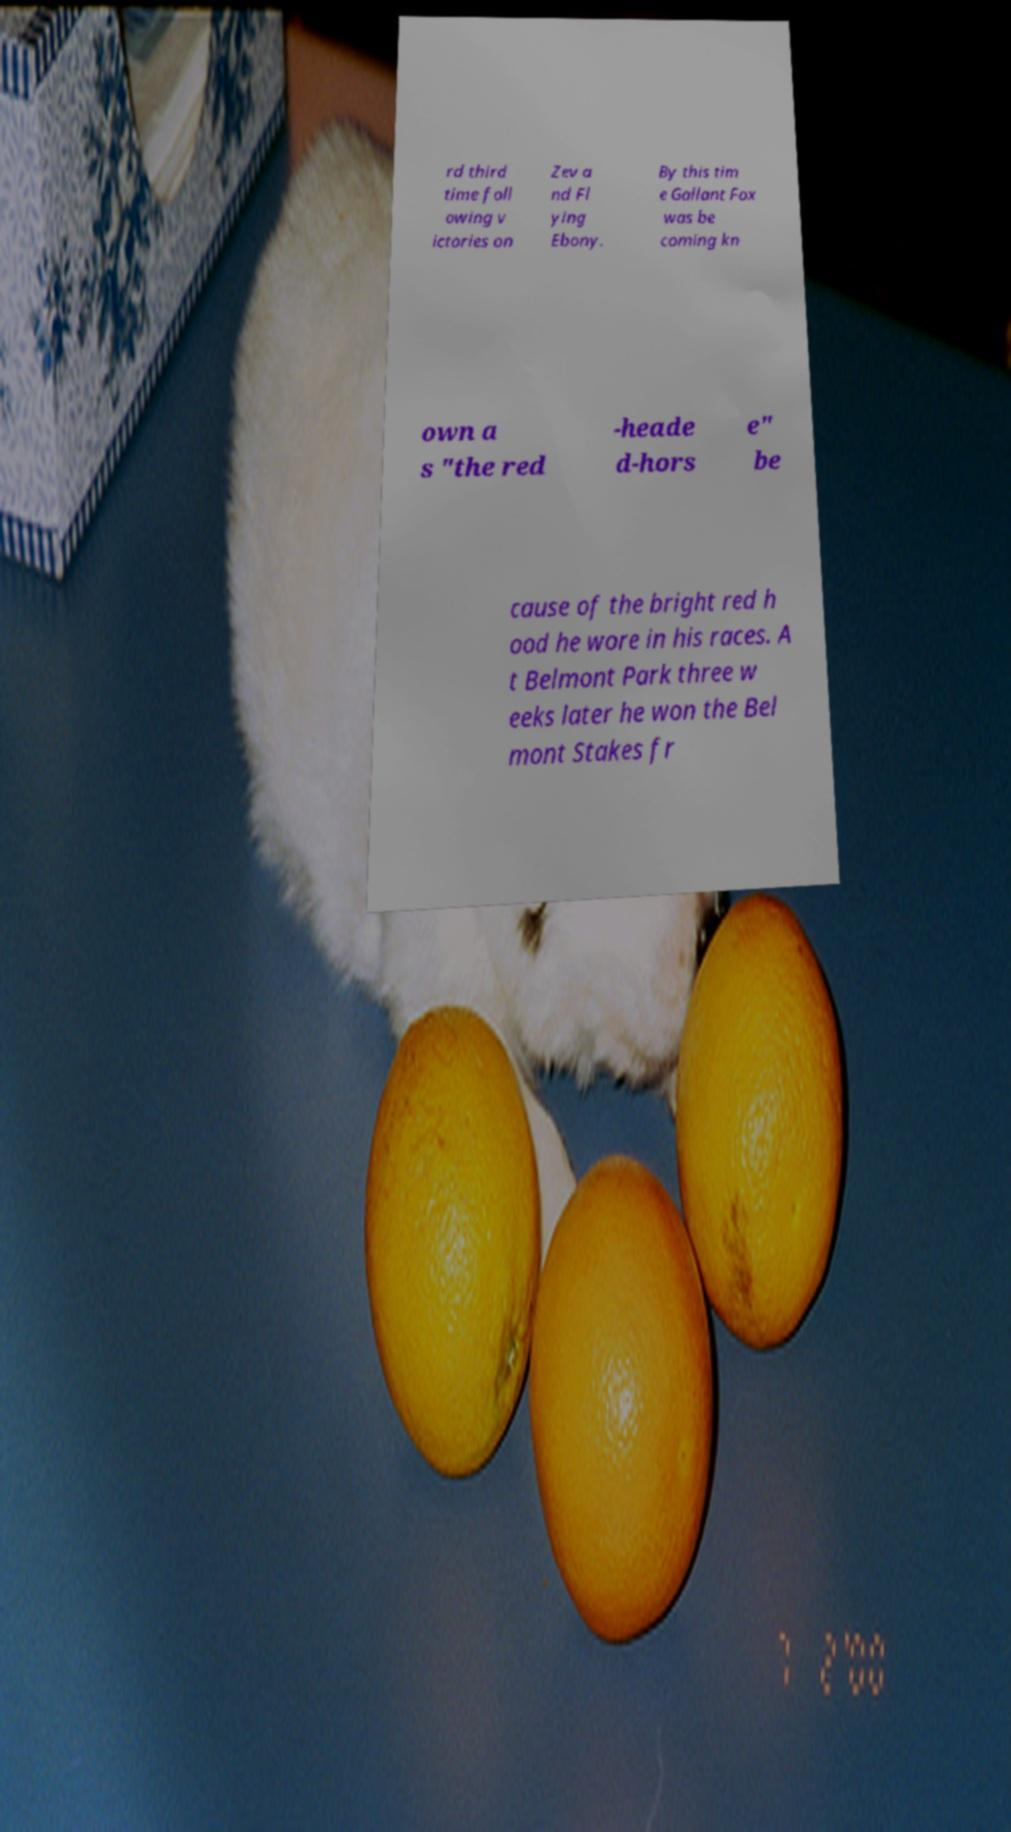For documentation purposes, I need the text within this image transcribed. Could you provide that? rd third time foll owing v ictories on Zev a nd Fl ying Ebony. By this tim e Gallant Fox was be coming kn own a s "the red -heade d-hors e" be cause of the bright red h ood he wore in his races. A t Belmont Park three w eeks later he won the Bel mont Stakes fr 